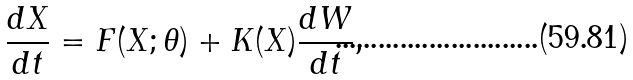<formula> <loc_0><loc_0><loc_500><loc_500>\frac { d X } { d t } = F ( X ; \theta ) + K ( X ) \frac { d W } { d t } ,</formula> 